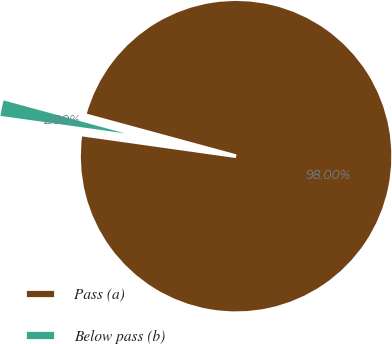Convert chart to OTSL. <chart><loc_0><loc_0><loc_500><loc_500><pie_chart><fcel>Pass (a)<fcel>Below pass (b)<nl><fcel>98.0%<fcel>2.0%<nl></chart> 